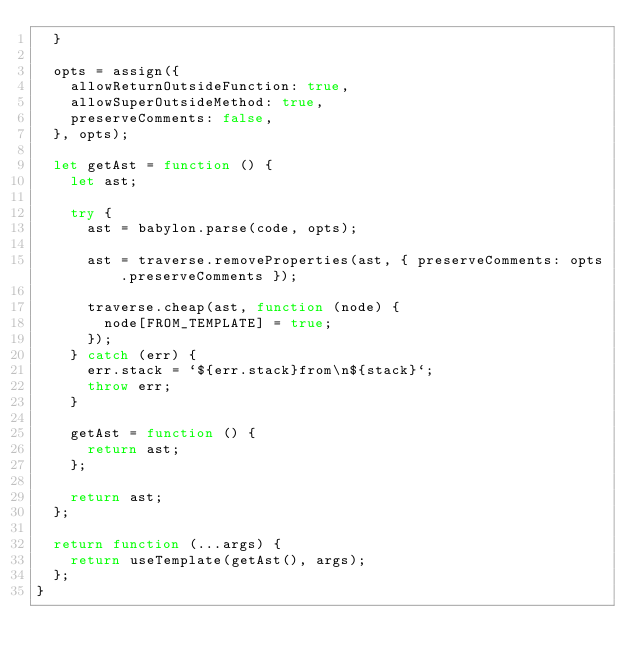<code> <loc_0><loc_0><loc_500><loc_500><_JavaScript_>  }

  opts = assign({
    allowReturnOutsideFunction: true,
    allowSuperOutsideMethod: true,
    preserveComments: false,
  }, opts);

  let getAst = function () {
    let ast;

    try {
      ast = babylon.parse(code, opts);

      ast = traverse.removeProperties(ast, { preserveComments: opts.preserveComments });

      traverse.cheap(ast, function (node) {
        node[FROM_TEMPLATE] = true;
      });
    } catch (err) {
      err.stack = `${err.stack}from\n${stack}`;
      throw err;
    }

    getAst = function () {
      return ast;
    };

    return ast;
  };

  return function (...args) {
    return useTemplate(getAst(), args);
  };
}
</code> 